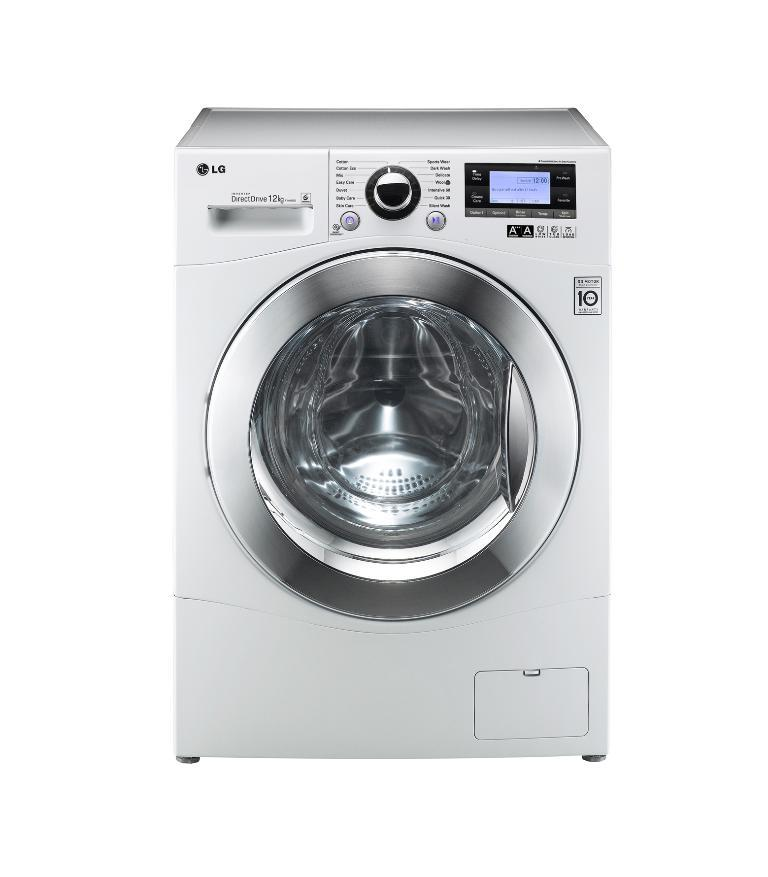What appliance is visible in the image? There is a washing machine in the image. What color is the background of the image? The background of the image is white. What phase is the moon in during the day depicted in the image? There is no moon visible in the image, and the time of day cannot be determined from the provided facts. 